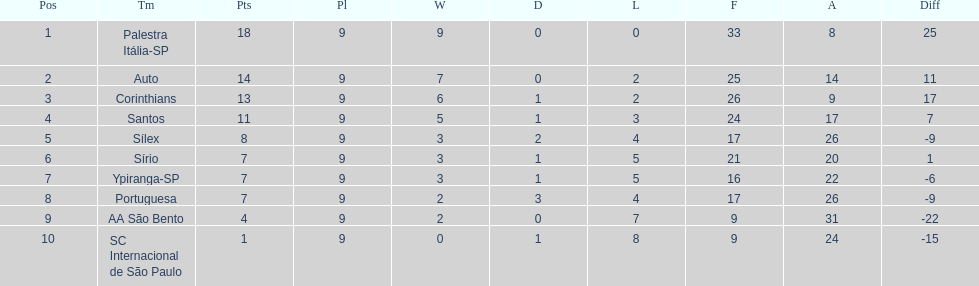In 1926 brazilian football, apart from the leading team, what other teams had successful records? Auto, Corinthians, Santos. 